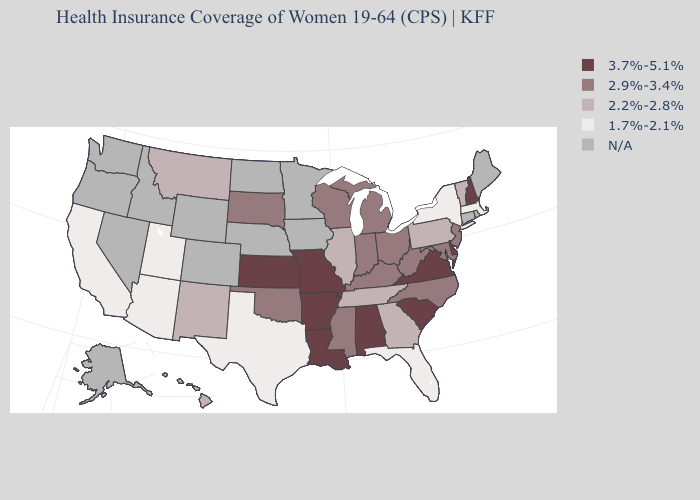Is the legend a continuous bar?
Write a very short answer. No. Name the states that have a value in the range 2.9%-3.4%?
Keep it brief. Indiana, Kentucky, Maryland, Michigan, Mississippi, New Jersey, North Carolina, Ohio, Oklahoma, South Dakota, West Virginia, Wisconsin. What is the highest value in the USA?
Concise answer only. 3.7%-5.1%. Does Florida have the lowest value in the USA?
Short answer required. Yes. What is the value of Vermont?
Write a very short answer. 2.2%-2.8%. Which states have the lowest value in the USA?
Give a very brief answer. Arizona, California, Florida, Massachusetts, New York, Texas, Utah. Name the states that have a value in the range 3.7%-5.1%?
Be succinct. Alabama, Arkansas, Delaware, Kansas, Louisiana, Missouri, New Hampshire, South Carolina, Virginia. What is the highest value in the MidWest ?
Quick response, please. 3.7%-5.1%. What is the value of South Carolina?
Be succinct. 3.7%-5.1%. What is the value of Massachusetts?
Write a very short answer. 1.7%-2.1%. What is the value of Michigan?
Be succinct. 2.9%-3.4%. What is the highest value in the West ?
Give a very brief answer. 2.2%-2.8%. Name the states that have a value in the range 1.7%-2.1%?
Concise answer only. Arizona, California, Florida, Massachusetts, New York, Texas, Utah. What is the lowest value in states that border Oregon?
Keep it brief. 1.7%-2.1%. 